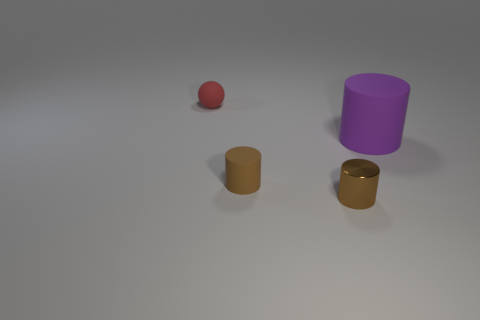Subtract all brown metallic cylinders. How many cylinders are left? 2 Subtract all green balls. How many brown cylinders are left? 2 Add 3 big blue rubber spheres. How many objects exist? 7 Subtract 1 cylinders. How many cylinders are left? 2 Add 3 tiny blue shiny cylinders. How many tiny blue shiny cylinders exist? 3 Subtract 0 red blocks. How many objects are left? 4 Subtract all balls. How many objects are left? 3 Subtract all blue cylinders. Subtract all purple balls. How many cylinders are left? 3 Subtract all brown metal cylinders. Subtract all tiny brown things. How many objects are left? 1 Add 3 tiny brown matte cylinders. How many tiny brown matte cylinders are left? 4 